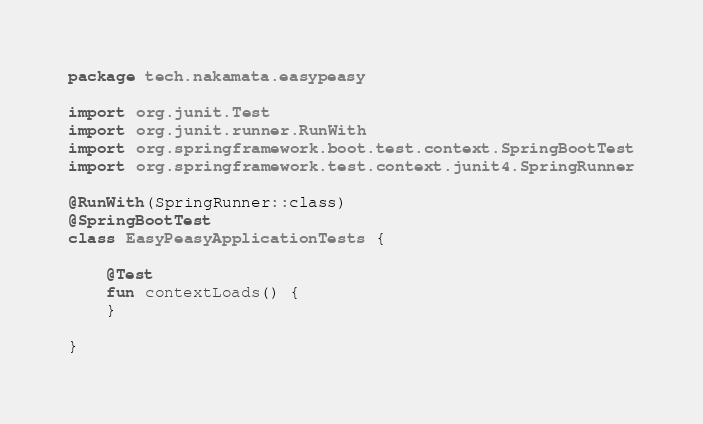Convert code to text. <code><loc_0><loc_0><loc_500><loc_500><_Kotlin_>package tech.nakamata.easypeasy

import org.junit.Test
import org.junit.runner.RunWith
import org.springframework.boot.test.context.SpringBootTest
import org.springframework.test.context.junit4.SpringRunner

@RunWith(SpringRunner::class)
@SpringBootTest
class EasyPeasyApplicationTests {

	@Test
	fun contextLoads() {
	}

}
</code> 